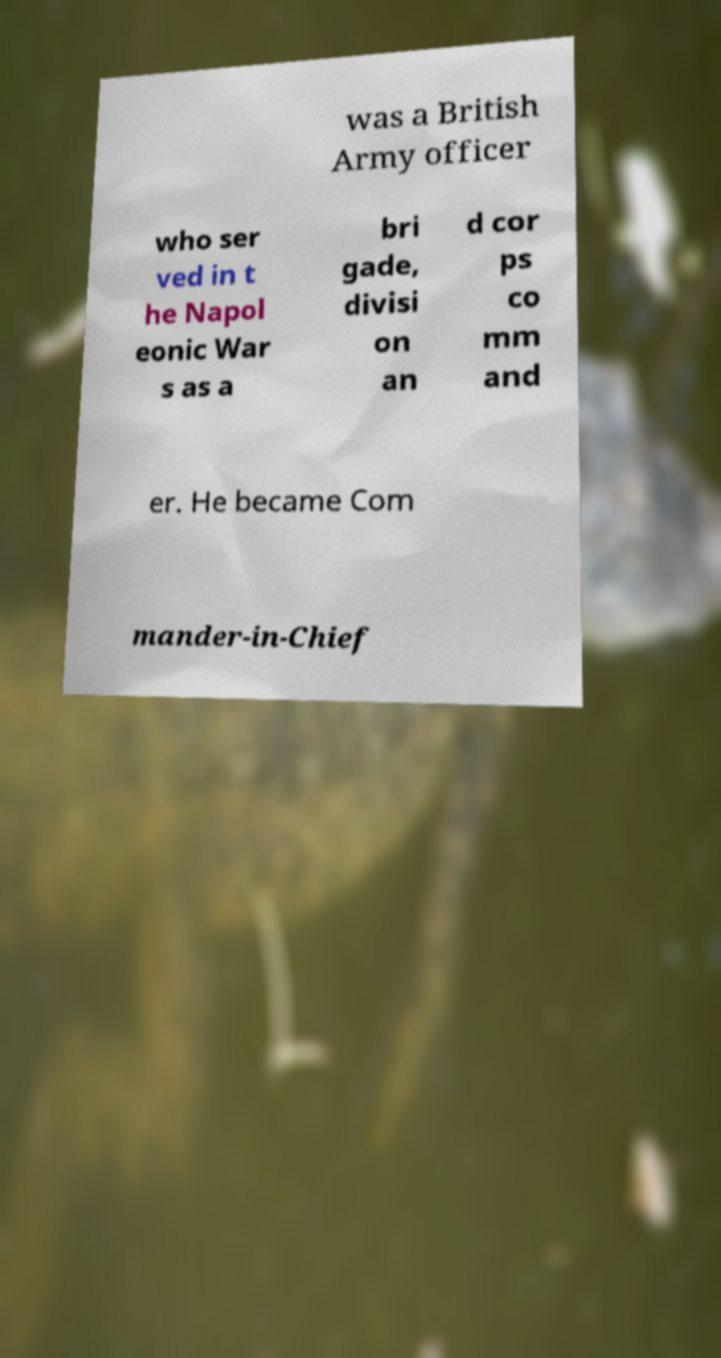Could you extract and type out the text from this image? was a British Army officer who ser ved in t he Napol eonic War s as a bri gade, divisi on an d cor ps co mm and er. He became Com mander-in-Chief 